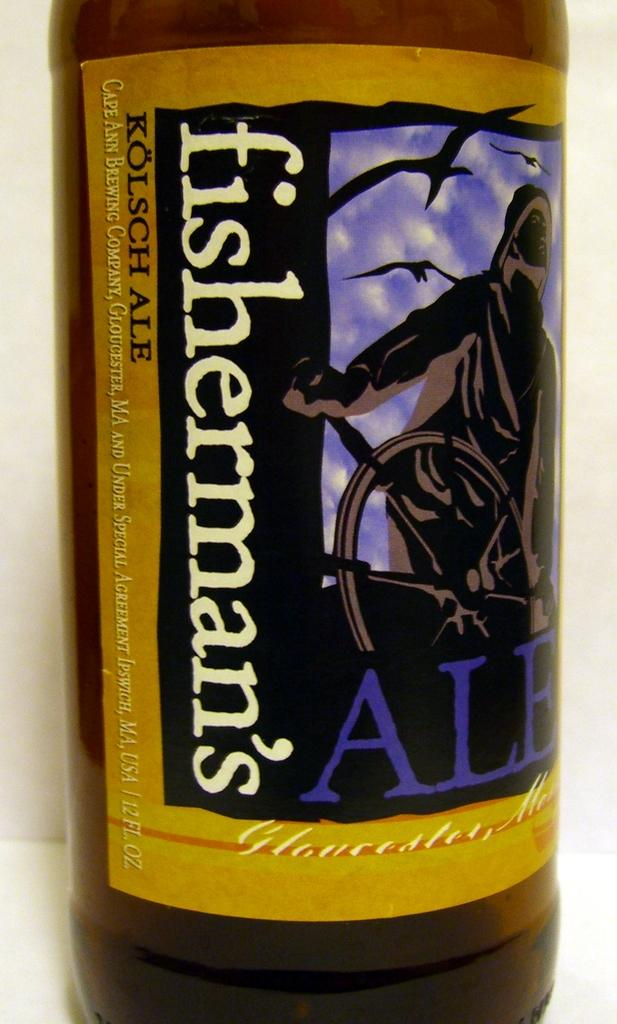<image>
Write a terse but informative summary of the picture. A bottle that is very zoomed into, with the brand of the drink in the bottle being Fisherman's. 